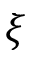Convert formula to latex. <formula><loc_0><loc_0><loc_500><loc_500>\xi</formula> 